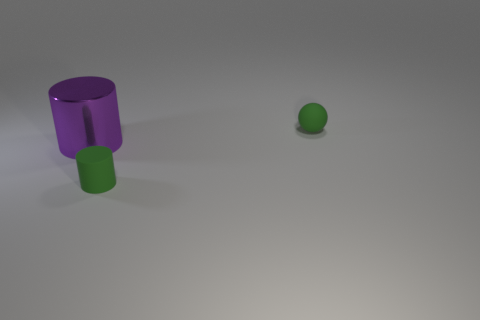Add 2 cylinders. How many objects exist? 5 Subtract all spheres. How many objects are left? 2 Add 3 cylinders. How many cylinders exist? 5 Subtract 0 cyan cylinders. How many objects are left? 3 Subtract all big purple matte cubes. Subtract all small green matte cylinders. How many objects are left? 2 Add 1 spheres. How many spheres are left? 2 